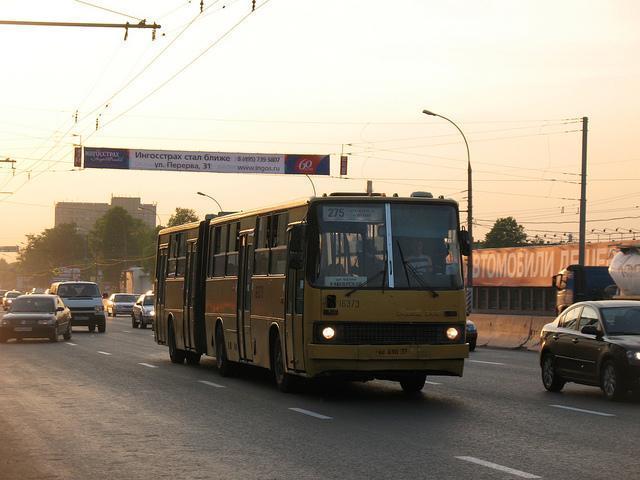How many cars can be seen?
Give a very brief answer. 2. How many bears are in the chair?
Give a very brief answer. 0. 